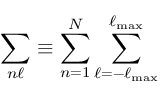Convert formula to latex. <formula><loc_0><loc_0><loc_500><loc_500>\sum _ { n \ell } \equiv \sum _ { n = 1 } ^ { N } \sum _ { \ell = - \ell _ { \max } } ^ { \ell _ { \max } }</formula> 